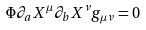<formula> <loc_0><loc_0><loc_500><loc_500>\Phi \partial _ { a } X ^ { \mu } \partial _ { b } X ^ { \nu } g _ { \mu \nu } = 0</formula> 